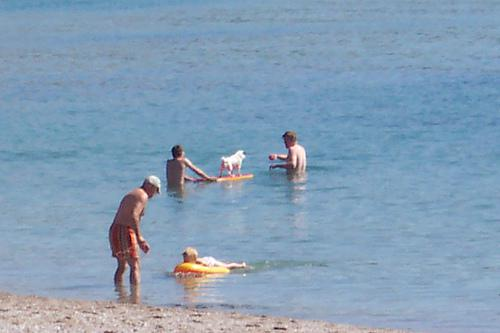Question: where is this located?
Choices:
A. The mountains.
B. The beach.
C. A park.
D. A ball field.
Answer with the letter. Answer: B Question: how many children are in the photo?
Choices:
A. 2.
B. 3.
C. 4.
D. 1.
Answer with the letter. Answer: D Question: how deep is the water under the man in front?
Choices:
A. Ankle deep.
B. Waist high.
C. Calf deep.
D. Thigh deep.
Answer with the letter. Answer: C 